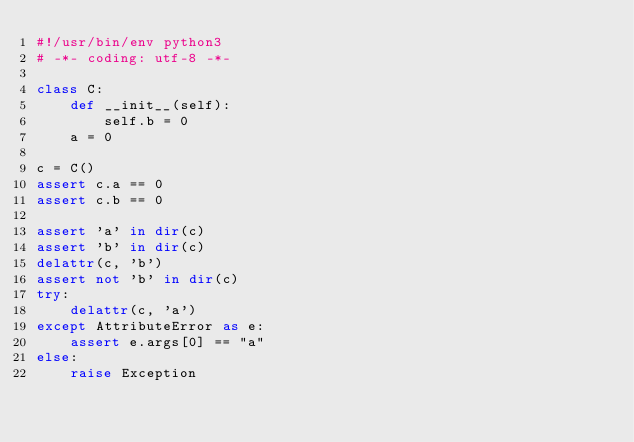Convert code to text. <code><loc_0><loc_0><loc_500><loc_500><_Python_>#!/usr/bin/env python3
# -*- coding: utf-8 -*-

class C:
    def __init__(self):
        self.b = 0
    a = 0

c = C()
assert c.a == 0
assert c.b == 0

assert 'a' in dir(c)
assert 'b' in dir(c)
delattr(c, 'b')
assert not 'b' in dir(c)
try:
    delattr(c, 'a')
except AttributeError as e:
    assert e.args[0] == "a"
else:
    raise Exception
</code> 